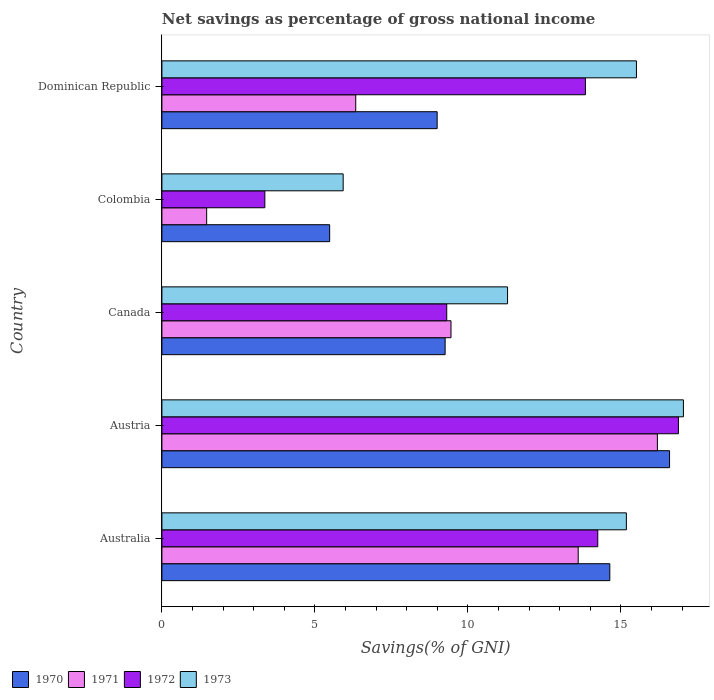Are the number of bars per tick equal to the number of legend labels?
Provide a succinct answer. Yes. How many bars are there on the 2nd tick from the bottom?
Offer a very short reply. 4. What is the label of the 3rd group of bars from the top?
Provide a short and direct response. Canada. In how many cases, is the number of bars for a given country not equal to the number of legend labels?
Your response must be concise. 0. What is the total savings in 1971 in Colombia?
Make the answer very short. 1.46. Across all countries, what is the maximum total savings in 1970?
Your response must be concise. 16.59. Across all countries, what is the minimum total savings in 1972?
Offer a terse response. 3.36. In which country was the total savings in 1972 maximum?
Make the answer very short. Austria. What is the total total savings in 1973 in the graph?
Ensure brevity in your answer.  64.94. What is the difference between the total savings in 1971 in Australia and that in Canada?
Your answer should be very brief. 4.16. What is the difference between the total savings in 1970 in Dominican Republic and the total savings in 1972 in Australia?
Your answer should be compact. -5.25. What is the average total savings in 1970 per country?
Provide a succinct answer. 10.99. What is the difference between the total savings in 1973 and total savings in 1970 in Dominican Republic?
Provide a short and direct response. 6.51. What is the ratio of the total savings in 1972 in Colombia to that in Dominican Republic?
Offer a very short reply. 0.24. Is the difference between the total savings in 1973 in Colombia and Dominican Republic greater than the difference between the total savings in 1970 in Colombia and Dominican Republic?
Provide a short and direct response. No. What is the difference between the highest and the second highest total savings in 1970?
Provide a short and direct response. 1.95. What is the difference between the highest and the lowest total savings in 1970?
Your answer should be very brief. 11.11. In how many countries, is the total savings in 1971 greater than the average total savings in 1971 taken over all countries?
Provide a succinct answer. 3. Is it the case that in every country, the sum of the total savings in 1972 and total savings in 1971 is greater than the total savings in 1970?
Make the answer very short. No. How many countries are there in the graph?
Provide a short and direct response. 5. What is the difference between two consecutive major ticks on the X-axis?
Provide a succinct answer. 5. Are the values on the major ticks of X-axis written in scientific E-notation?
Offer a very short reply. No. Does the graph contain any zero values?
Provide a short and direct response. No. Does the graph contain grids?
Your answer should be very brief. No. Where does the legend appear in the graph?
Give a very brief answer. Bottom left. How many legend labels are there?
Your response must be concise. 4. How are the legend labels stacked?
Offer a very short reply. Horizontal. What is the title of the graph?
Give a very brief answer. Net savings as percentage of gross national income. Does "1987" appear as one of the legend labels in the graph?
Ensure brevity in your answer.  No. What is the label or title of the X-axis?
Your answer should be very brief. Savings(% of GNI). What is the Savings(% of GNI) of 1970 in Australia?
Provide a short and direct response. 14.63. What is the Savings(% of GNI) in 1971 in Australia?
Your answer should be very brief. 13.6. What is the Savings(% of GNI) of 1972 in Australia?
Ensure brevity in your answer.  14.24. What is the Savings(% of GNI) in 1973 in Australia?
Give a very brief answer. 15.18. What is the Savings(% of GNI) of 1970 in Austria?
Your response must be concise. 16.59. What is the Savings(% of GNI) in 1971 in Austria?
Give a very brief answer. 16.19. What is the Savings(% of GNI) in 1972 in Austria?
Make the answer very short. 16.88. What is the Savings(% of GNI) in 1973 in Austria?
Your answer should be very brief. 17.04. What is the Savings(% of GNI) of 1970 in Canada?
Offer a very short reply. 9.25. What is the Savings(% of GNI) of 1971 in Canada?
Provide a short and direct response. 9.45. What is the Savings(% of GNI) in 1972 in Canada?
Keep it short and to the point. 9.31. What is the Savings(% of GNI) in 1973 in Canada?
Offer a terse response. 11.29. What is the Savings(% of GNI) of 1970 in Colombia?
Offer a terse response. 5.48. What is the Savings(% of GNI) of 1971 in Colombia?
Offer a very short reply. 1.46. What is the Savings(% of GNI) of 1972 in Colombia?
Provide a succinct answer. 3.36. What is the Savings(% of GNI) of 1973 in Colombia?
Offer a terse response. 5.92. What is the Savings(% of GNI) of 1970 in Dominican Republic?
Give a very brief answer. 8.99. What is the Savings(% of GNI) in 1971 in Dominican Republic?
Provide a succinct answer. 6.33. What is the Savings(% of GNI) of 1972 in Dominican Republic?
Keep it short and to the point. 13.84. What is the Savings(% of GNI) of 1973 in Dominican Republic?
Give a very brief answer. 15.5. Across all countries, what is the maximum Savings(% of GNI) of 1970?
Give a very brief answer. 16.59. Across all countries, what is the maximum Savings(% of GNI) of 1971?
Offer a terse response. 16.19. Across all countries, what is the maximum Savings(% of GNI) of 1972?
Keep it short and to the point. 16.88. Across all countries, what is the maximum Savings(% of GNI) in 1973?
Your answer should be very brief. 17.04. Across all countries, what is the minimum Savings(% of GNI) of 1970?
Your response must be concise. 5.48. Across all countries, what is the minimum Savings(% of GNI) of 1971?
Offer a very short reply. 1.46. Across all countries, what is the minimum Savings(% of GNI) of 1972?
Give a very brief answer. 3.36. Across all countries, what is the minimum Savings(% of GNI) of 1973?
Your answer should be compact. 5.92. What is the total Savings(% of GNI) in 1970 in the graph?
Provide a short and direct response. 54.95. What is the total Savings(% of GNI) in 1971 in the graph?
Give a very brief answer. 47.03. What is the total Savings(% of GNI) in 1972 in the graph?
Give a very brief answer. 57.63. What is the total Savings(% of GNI) of 1973 in the graph?
Your answer should be very brief. 64.94. What is the difference between the Savings(% of GNI) of 1970 in Australia and that in Austria?
Keep it short and to the point. -1.95. What is the difference between the Savings(% of GNI) of 1971 in Australia and that in Austria?
Provide a short and direct response. -2.59. What is the difference between the Savings(% of GNI) in 1972 in Australia and that in Austria?
Your response must be concise. -2.64. What is the difference between the Savings(% of GNI) of 1973 in Australia and that in Austria?
Provide a short and direct response. -1.86. What is the difference between the Savings(% of GNI) of 1970 in Australia and that in Canada?
Give a very brief answer. 5.38. What is the difference between the Savings(% of GNI) in 1971 in Australia and that in Canada?
Your answer should be compact. 4.16. What is the difference between the Savings(% of GNI) in 1972 in Australia and that in Canada?
Offer a terse response. 4.93. What is the difference between the Savings(% of GNI) in 1973 in Australia and that in Canada?
Provide a succinct answer. 3.88. What is the difference between the Savings(% of GNI) of 1970 in Australia and that in Colombia?
Offer a very short reply. 9.15. What is the difference between the Savings(% of GNI) in 1971 in Australia and that in Colombia?
Your answer should be very brief. 12.14. What is the difference between the Savings(% of GNI) in 1972 in Australia and that in Colombia?
Offer a very short reply. 10.88. What is the difference between the Savings(% of GNI) in 1973 in Australia and that in Colombia?
Give a very brief answer. 9.25. What is the difference between the Savings(% of GNI) in 1970 in Australia and that in Dominican Republic?
Your response must be concise. 5.64. What is the difference between the Savings(% of GNI) of 1971 in Australia and that in Dominican Republic?
Your answer should be compact. 7.27. What is the difference between the Savings(% of GNI) of 1972 in Australia and that in Dominican Republic?
Provide a short and direct response. 0.4. What is the difference between the Savings(% of GNI) in 1973 in Australia and that in Dominican Republic?
Your response must be concise. -0.33. What is the difference between the Savings(% of GNI) of 1970 in Austria and that in Canada?
Keep it short and to the point. 7.33. What is the difference between the Savings(% of GNI) of 1971 in Austria and that in Canada?
Your response must be concise. 6.74. What is the difference between the Savings(% of GNI) in 1972 in Austria and that in Canada?
Provide a succinct answer. 7.57. What is the difference between the Savings(% of GNI) of 1973 in Austria and that in Canada?
Provide a short and direct response. 5.75. What is the difference between the Savings(% of GNI) of 1970 in Austria and that in Colombia?
Your answer should be very brief. 11.11. What is the difference between the Savings(% of GNI) in 1971 in Austria and that in Colombia?
Ensure brevity in your answer.  14.73. What is the difference between the Savings(% of GNI) of 1972 in Austria and that in Colombia?
Your answer should be compact. 13.51. What is the difference between the Savings(% of GNI) in 1973 in Austria and that in Colombia?
Keep it short and to the point. 11.12. What is the difference between the Savings(% of GNI) in 1970 in Austria and that in Dominican Republic?
Offer a terse response. 7.59. What is the difference between the Savings(% of GNI) of 1971 in Austria and that in Dominican Republic?
Make the answer very short. 9.86. What is the difference between the Savings(% of GNI) of 1972 in Austria and that in Dominican Republic?
Your answer should be very brief. 3.04. What is the difference between the Savings(% of GNI) of 1973 in Austria and that in Dominican Republic?
Offer a very short reply. 1.54. What is the difference between the Savings(% of GNI) in 1970 in Canada and that in Colombia?
Provide a succinct answer. 3.77. What is the difference between the Savings(% of GNI) in 1971 in Canada and that in Colombia?
Keep it short and to the point. 7.98. What is the difference between the Savings(% of GNI) in 1972 in Canada and that in Colombia?
Ensure brevity in your answer.  5.94. What is the difference between the Savings(% of GNI) of 1973 in Canada and that in Colombia?
Provide a succinct answer. 5.37. What is the difference between the Savings(% of GNI) in 1970 in Canada and that in Dominican Republic?
Offer a very short reply. 0.26. What is the difference between the Savings(% of GNI) in 1971 in Canada and that in Dominican Republic?
Ensure brevity in your answer.  3.11. What is the difference between the Savings(% of GNI) in 1972 in Canada and that in Dominican Republic?
Make the answer very short. -4.53. What is the difference between the Savings(% of GNI) in 1973 in Canada and that in Dominican Republic?
Ensure brevity in your answer.  -4.21. What is the difference between the Savings(% of GNI) of 1970 in Colombia and that in Dominican Republic?
Offer a terse response. -3.51. What is the difference between the Savings(% of GNI) of 1971 in Colombia and that in Dominican Republic?
Offer a very short reply. -4.87. What is the difference between the Savings(% of GNI) in 1972 in Colombia and that in Dominican Republic?
Your answer should be very brief. -10.47. What is the difference between the Savings(% of GNI) of 1973 in Colombia and that in Dominican Republic?
Keep it short and to the point. -9.58. What is the difference between the Savings(% of GNI) in 1970 in Australia and the Savings(% of GNI) in 1971 in Austria?
Ensure brevity in your answer.  -1.55. What is the difference between the Savings(% of GNI) in 1970 in Australia and the Savings(% of GNI) in 1972 in Austria?
Your answer should be very brief. -2.24. What is the difference between the Savings(% of GNI) in 1970 in Australia and the Savings(% of GNI) in 1973 in Austria?
Provide a succinct answer. -2.4. What is the difference between the Savings(% of GNI) in 1971 in Australia and the Savings(% of GNI) in 1972 in Austria?
Ensure brevity in your answer.  -3.27. What is the difference between the Savings(% of GNI) in 1971 in Australia and the Savings(% of GNI) in 1973 in Austria?
Provide a short and direct response. -3.44. What is the difference between the Savings(% of GNI) in 1972 in Australia and the Savings(% of GNI) in 1973 in Austria?
Provide a short and direct response. -2.8. What is the difference between the Savings(% of GNI) in 1970 in Australia and the Savings(% of GNI) in 1971 in Canada?
Provide a short and direct response. 5.19. What is the difference between the Savings(% of GNI) of 1970 in Australia and the Savings(% of GNI) of 1972 in Canada?
Offer a very short reply. 5.33. What is the difference between the Savings(% of GNI) in 1970 in Australia and the Savings(% of GNI) in 1973 in Canada?
Keep it short and to the point. 3.34. What is the difference between the Savings(% of GNI) in 1971 in Australia and the Savings(% of GNI) in 1972 in Canada?
Offer a very short reply. 4.3. What is the difference between the Savings(% of GNI) in 1971 in Australia and the Savings(% of GNI) in 1973 in Canada?
Ensure brevity in your answer.  2.31. What is the difference between the Savings(% of GNI) of 1972 in Australia and the Savings(% of GNI) of 1973 in Canada?
Your answer should be very brief. 2.95. What is the difference between the Savings(% of GNI) of 1970 in Australia and the Savings(% of GNI) of 1971 in Colombia?
Keep it short and to the point. 13.17. What is the difference between the Savings(% of GNI) in 1970 in Australia and the Savings(% of GNI) in 1972 in Colombia?
Offer a very short reply. 11.27. What is the difference between the Savings(% of GNI) in 1970 in Australia and the Savings(% of GNI) in 1973 in Colombia?
Your answer should be compact. 8.71. What is the difference between the Savings(% of GNI) in 1971 in Australia and the Savings(% of GNI) in 1972 in Colombia?
Offer a very short reply. 10.24. What is the difference between the Savings(% of GNI) in 1971 in Australia and the Savings(% of GNI) in 1973 in Colombia?
Make the answer very short. 7.68. What is the difference between the Savings(% of GNI) of 1972 in Australia and the Savings(% of GNI) of 1973 in Colombia?
Provide a succinct answer. 8.32. What is the difference between the Savings(% of GNI) of 1970 in Australia and the Savings(% of GNI) of 1971 in Dominican Republic?
Ensure brevity in your answer.  8.3. What is the difference between the Savings(% of GNI) in 1970 in Australia and the Savings(% of GNI) in 1972 in Dominican Republic?
Your answer should be compact. 0.8. What is the difference between the Savings(% of GNI) of 1970 in Australia and the Savings(% of GNI) of 1973 in Dominican Republic?
Your answer should be very brief. -0.87. What is the difference between the Savings(% of GNI) in 1971 in Australia and the Savings(% of GNI) in 1972 in Dominican Republic?
Your answer should be very brief. -0.24. What is the difference between the Savings(% of GNI) of 1971 in Australia and the Savings(% of GNI) of 1973 in Dominican Republic?
Make the answer very short. -1.9. What is the difference between the Savings(% of GNI) of 1972 in Australia and the Savings(% of GNI) of 1973 in Dominican Republic?
Make the answer very short. -1.26. What is the difference between the Savings(% of GNI) of 1970 in Austria and the Savings(% of GNI) of 1971 in Canada?
Make the answer very short. 7.14. What is the difference between the Savings(% of GNI) of 1970 in Austria and the Savings(% of GNI) of 1972 in Canada?
Ensure brevity in your answer.  7.28. What is the difference between the Savings(% of GNI) of 1970 in Austria and the Savings(% of GNI) of 1973 in Canada?
Give a very brief answer. 5.29. What is the difference between the Savings(% of GNI) in 1971 in Austria and the Savings(% of GNI) in 1972 in Canada?
Provide a succinct answer. 6.88. What is the difference between the Savings(% of GNI) of 1971 in Austria and the Savings(% of GNI) of 1973 in Canada?
Your answer should be very brief. 4.9. What is the difference between the Savings(% of GNI) of 1972 in Austria and the Savings(% of GNI) of 1973 in Canada?
Offer a very short reply. 5.58. What is the difference between the Savings(% of GNI) in 1970 in Austria and the Savings(% of GNI) in 1971 in Colombia?
Provide a succinct answer. 15.12. What is the difference between the Savings(% of GNI) of 1970 in Austria and the Savings(% of GNI) of 1972 in Colombia?
Offer a terse response. 13.22. What is the difference between the Savings(% of GNI) of 1970 in Austria and the Savings(% of GNI) of 1973 in Colombia?
Provide a succinct answer. 10.66. What is the difference between the Savings(% of GNI) in 1971 in Austria and the Savings(% of GNI) in 1972 in Colombia?
Your answer should be compact. 12.83. What is the difference between the Savings(% of GNI) in 1971 in Austria and the Savings(% of GNI) in 1973 in Colombia?
Provide a succinct answer. 10.27. What is the difference between the Savings(% of GNI) of 1972 in Austria and the Savings(% of GNI) of 1973 in Colombia?
Make the answer very short. 10.95. What is the difference between the Savings(% of GNI) in 1970 in Austria and the Savings(% of GNI) in 1971 in Dominican Republic?
Offer a very short reply. 10.25. What is the difference between the Savings(% of GNI) of 1970 in Austria and the Savings(% of GNI) of 1972 in Dominican Republic?
Keep it short and to the point. 2.75. What is the difference between the Savings(% of GNI) in 1970 in Austria and the Savings(% of GNI) in 1973 in Dominican Republic?
Provide a succinct answer. 1.08. What is the difference between the Savings(% of GNI) of 1971 in Austria and the Savings(% of GNI) of 1972 in Dominican Republic?
Provide a short and direct response. 2.35. What is the difference between the Savings(% of GNI) in 1971 in Austria and the Savings(% of GNI) in 1973 in Dominican Republic?
Your response must be concise. 0.69. What is the difference between the Savings(% of GNI) of 1972 in Austria and the Savings(% of GNI) of 1973 in Dominican Republic?
Provide a succinct answer. 1.37. What is the difference between the Savings(% of GNI) in 1970 in Canada and the Savings(% of GNI) in 1971 in Colombia?
Provide a succinct answer. 7.79. What is the difference between the Savings(% of GNI) of 1970 in Canada and the Savings(% of GNI) of 1972 in Colombia?
Offer a very short reply. 5.89. What is the difference between the Savings(% of GNI) of 1970 in Canada and the Savings(% of GNI) of 1973 in Colombia?
Make the answer very short. 3.33. What is the difference between the Savings(% of GNI) of 1971 in Canada and the Savings(% of GNI) of 1972 in Colombia?
Provide a short and direct response. 6.08. What is the difference between the Savings(% of GNI) of 1971 in Canada and the Savings(% of GNI) of 1973 in Colombia?
Ensure brevity in your answer.  3.52. What is the difference between the Savings(% of GNI) of 1972 in Canada and the Savings(% of GNI) of 1973 in Colombia?
Keep it short and to the point. 3.38. What is the difference between the Savings(% of GNI) in 1970 in Canada and the Savings(% of GNI) in 1971 in Dominican Republic?
Your answer should be compact. 2.92. What is the difference between the Savings(% of GNI) in 1970 in Canada and the Savings(% of GNI) in 1972 in Dominican Republic?
Your answer should be very brief. -4.58. What is the difference between the Savings(% of GNI) in 1970 in Canada and the Savings(% of GNI) in 1973 in Dominican Republic?
Provide a short and direct response. -6.25. What is the difference between the Savings(% of GNI) of 1971 in Canada and the Savings(% of GNI) of 1972 in Dominican Republic?
Your answer should be very brief. -4.39. What is the difference between the Savings(% of GNI) of 1971 in Canada and the Savings(% of GNI) of 1973 in Dominican Republic?
Make the answer very short. -6.06. What is the difference between the Savings(% of GNI) in 1972 in Canada and the Savings(% of GNI) in 1973 in Dominican Republic?
Offer a terse response. -6.2. What is the difference between the Savings(% of GNI) of 1970 in Colombia and the Savings(% of GNI) of 1971 in Dominican Republic?
Your answer should be very brief. -0.85. What is the difference between the Savings(% of GNI) in 1970 in Colombia and the Savings(% of GNI) in 1972 in Dominican Republic?
Make the answer very short. -8.36. What is the difference between the Savings(% of GNI) in 1970 in Colombia and the Savings(% of GNI) in 1973 in Dominican Republic?
Keep it short and to the point. -10.02. What is the difference between the Savings(% of GNI) of 1971 in Colombia and the Savings(% of GNI) of 1972 in Dominican Republic?
Your response must be concise. -12.38. What is the difference between the Savings(% of GNI) in 1971 in Colombia and the Savings(% of GNI) in 1973 in Dominican Republic?
Offer a terse response. -14.04. What is the difference between the Savings(% of GNI) of 1972 in Colombia and the Savings(% of GNI) of 1973 in Dominican Republic?
Ensure brevity in your answer.  -12.14. What is the average Savings(% of GNI) in 1970 per country?
Give a very brief answer. 10.99. What is the average Savings(% of GNI) of 1971 per country?
Your response must be concise. 9.41. What is the average Savings(% of GNI) in 1972 per country?
Ensure brevity in your answer.  11.53. What is the average Savings(% of GNI) in 1973 per country?
Provide a short and direct response. 12.99. What is the difference between the Savings(% of GNI) in 1970 and Savings(% of GNI) in 1971 in Australia?
Keep it short and to the point. 1.03. What is the difference between the Savings(% of GNI) of 1970 and Savings(% of GNI) of 1972 in Australia?
Ensure brevity in your answer.  0.39. What is the difference between the Savings(% of GNI) of 1970 and Savings(% of GNI) of 1973 in Australia?
Provide a succinct answer. -0.54. What is the difference between the Savings(% of GNI) in 1971 and Savings(% of GNI) in 1972 in Australia?
Your response must be concise. -0.64. What is the difference between the Savings(% of GNI) in 1971 and Savings(% of GNI) in 1973 in Australia?
Give a very brief answer. -1.57. What is the difference between the Savings(% of GNI) in 1972 and Savings(% of GNI) in 1973 in Australia?
Provide a succinct answer. -0.93. What is the difference between the Savings(% of GNI) of 1970 and Savings(% of GNI) of 1971 in Austria?
Your answer should be compact. 0.4. What is the difference between the Savings(% of GNI) of 1970 and Savings(% of GNI) of 1972 in Austria?
Give a very brief answer. -0.29. What is the difference between the Savings(% of GNI) in 1970 and Savings(% of GNI) in 1973 in Austria?
Give a very brief answer. -0.45. What is the difference between the Savings(% of GNI) in 1971 and Savings(% of GNI) in 1972 in Austria?
Provide a succinct answer. -0.69. What is the difference between the Savings(% of GNI) of 1971 and Savings(% of GNI) of 1973 in Austria?
Offer a very short reply. -0.85. What is the difference between the Savings(% of GNI) in 1972 and Savings(% of GNI) in 1973 in Austria?
Make the answer very short. -0.16. What is the difference between the Savings(% of GNI) of 1970 and Savings(% of GNI) of 1971 in Canada?
Provide a short and direct response. -0.19. What is the difference between the Savings(% of GNI) in 1970 and Savings(% of GNI) in 1972 in Canada?
Your response must be concise. -0.05. What is the difference between the Savings(% of GNI) in 1970 and Savings(% of GNI) in 1973 in Canada?
Make the answer very short. -2.04. What is the difference between the Savings(% of GNI) in 1971 and Savings(% of GNI) in 1972 in Canada?
Provide a succinct answer. 0.14. What is the difference between the Savings(% of GNI) of 1971 and Savings(% of GNI) of 1973 in Canada?
Your answer should be very brief. -1.85. What is the difference between the Savings(% of GNI) of 1972 and Savings(% of GNI) of 1973 in Canada?
Keep it short and to the point. -1.99. What is the difference between the Savings(% of GNI) in 1970 and Savings(% of GNI) in 1971 in Colombia?
Provide a short and direct response. 4.02. What is the difference between the Savings(% of GNI) of 1970 and Savings(% of GNI) of 1972 in Colombia?
Give a very brief answer. 2.12. What is the difference between the Savings(% of GNI) in 1970 and Savings(% of GNI) in 1973 in Colombia?
Give a very brief answer. -0.44. What is the difference between the Savings(% of GNI) in 1971 and Savings(% of GNI) in 1972 in Colombia?
Give a very brief answer. -1.9. What is the difference between the Savings(% of GNI) of 1971 and Savings(% of GNI) of 1973 in Colombia?
Make the answer very short. -4.46. What is the difference between the Savings(% of GNI) of 1972 and Savings(% of GNI) of 1973 in Colombia?
Offer a very short reply. -2.56. What is the difference between the Savings(% of GNI) of 1970 and Savings(% of GNI) of 1971 in Dominican Republic?
Keep it short and to the point. 2.66. What is the difference between the Savings(% of GNI) of 1970 and Savings(% of GNI) of 1972 in Dominican Republic?
Your answer should be very brief. -4.84. What is the difference between the Savings(% of GNI) of 1970 and Savings(% of GNI) of 1973 in Dominican Republic?
Offer a terse response. -6.51. What is the difference between the Savings(% of GNI) of 1971 and Savings(% of GNI) of 1972 in Dominican Republic?
Offer a very short reply. -7.5. What is the difference between the Savings(% of GNI) of 1971 and Savings(% of GNI) of 1973 in Dominican Republic?
Keep it short and to the point. -9.17. What is the difference between the Savings(% of GNI) in 1972 and Savings(% of GNI) in 1973 in Dominican Republic?
Offer a terse response. -1.67. What is the ratio of the Savings(% of GNI) in 1970 in Australia to that in Austria?
Your response must be concise. 0.88. What is the ratio of the Savings(% of GNI) in 1971 in Australia to that in Austria?
Give a very brief answer. 0.84. What is the ratio of the Savings(% of GNI) in 1972 in Australia to that in Austria?
Provide a succinct answer. 0.84. What is the ratio of the Savings(% of GNI) in 1973 in Australia to that in Austria?
Make the answer very short. 0.89. What is the ratio of the Savings(% of GNI) in 1970 in Australia to that in Canada?
Your answer should be very brief. 1.58. What is the ratio of the Savings(% of GNI) of 1971 in Australia to that in Canada?
Offer a terse response. 1.44. What is the ratio of the Savings(% of GNI) of 1972 in Australia to that in Canada?
Your answer should be very brief. 1.53. What is the ratio of the Savings(% of GNI) in 1973 in Australia to that in Canada?
Your response must be concise. 1.34. What is the ratio of the Savings(% of GNI) in 1970 in Australia to that in Colombia?
Your response must be concise. 2.67. What is the ratio of the Savings(% of GNI) of 1971 in Australia to that in Colombia?
Keep it short and to the point. 9.3. What is the ratio of the Savings(% of GNI) of 1972 in Australia to that in Colombia?
Keep it short and to the point. 4.23. What is the ratio of the Savings(% of GNI) of 1973 in Australia to that in Colombia?
Offer a very short reply. 2.56. What is the ratio of the Savings(% of GNI) in 1970 in Australia to that in Dominican Republic?
Offer a very short reply. 1.63. What is the ratio of the Savings(% of GNI) of 1971 in Australia to that in Dominican Republic?
Provide a short and direct response. 2.15. What is the ratio of the Savings(% of GNI) of 1972 in Australia to that in Dominican Republic?
Your response must be concise. 1.03. What is the ratio of the Savings(% of GNI) of 1973 in Australia to that in Dominican Republic?
Offer a terse response. 0.98. What is the ratio of the Savings(% of GNI) of 1970 in Austria to that in Canada?
Your answer should be very brief. 1.79. What is the ratio of the Savings(% of GNI) of 1971 in Austria to that in Canada?
Make the answer very short. 1.71. What is the ratio of the Savings(% of GNI) of 1972 in Austria to that in Canada?
Ensure brevity in your answer.  1.81. What is the ratio of the Savings(% of GNI) in 1973 in Austria to that in Canada?
Give a very brief answer. 1.51. What is the ratio of the Savings(% of GNI) of 1970 in Austria to that in Colombia?
Your answer should be compact. 3.03. What is the ratio of the Savings(% of GNI) in 1971 in Austria to that in Colombia?
Your response must be concise. 11.07. What is the ratio of the Savings(% of GNI) in 1972 in Austria to that in Colombia?
Give a very brief answer. 5.02. What is the ratio of the Savings(% of GNI) of 1973 in Austria to that in Colombia?
Your answer should be compact. 2.88. What is the ratio of the Savings(% of GNI) in 1970 in Austria to that in Dominican Republic?
Make the answer very short. 1.84. What is the ratio of the Savings(% of GNI) in 1971 in Austria to that in Dominican Republic?
Offer a very short reply. 2.56. What is the ratio of the Savings(% of GNI) in 1972 in Austria to that in Dominican Republic?
Keep it short and to the point. 1.22. What is the ratio of the Savings(% of GNI) of 1973 in Austria to that in Dominican Republic?
Your response must be concise. 1.1. What is the ratio of the Savings(% of GNI) of 1970 in Canada to that in Colombia?
Make the answer very short. 1.69. What is the ratio of the Savings(% of GNI) in 1971 in Canada to that in Colombia?
Provide a succinct answer. 6.46. What is the ratio of the Savings(% of GNI) of 1972 in Canada to that in Colombia?
Your response must be concise. 2.77. What is the ratio of the Savings(% of GNI) in 1973 in Canada to that in Colombia?
Your answer should be compact. 1.91. What is the ratio of the Savings(% of GNI) in 1971 in Canada to that in Dominican Republic?
Your answer should be very brief. 1.49. What is the ratio of the Savings(% of GNI) in 1972 in Canada to that in Dominican Republic?
Ensure brevity in your answer.  0.67. What is the ratio of the Savings(% of GNI) in 1973 in Canada to that in Dominican Republic?
Your answer should be very brief. 0.73. What is the ratio of the Savings(% of GNI) in 1970 in Colombia to that in Dominican Republic?
Keep it short and to the point. 0.61. What is the ratio of the Savings(% of GNI) in 1971 in Colombia to that in Dominican Republic?
Provide a succinct answer. 0.23. What is the ratio of the Savings(% of GNI) in 1972 in Colombia to that in Dominican Republic?
Your answer should be compact. 0.24. What is the ratio of the Savings(% of GNI) of 1973 in Colombia to that in Dominican Republic?
Provide a succinct answer. 0.38. What is the difference between the highest and the second highest Savings(% of GNI) in 1970?
Give a very brief answer. 1.95. What is the difference between the highest and the second highest Savings(% of GNI) of 1971?
Provide a succinct answer. 2.59. What is the difference between the highest and the second highest Savings(% of GNI) of 1972?
Provide a succinct answer. 2.64. What is the difference between the highest and the second highest Savings(% of GNI) in 1973?
Provide a short and direct response. 1.54. What is the difference between the highest and the lowest Savings(% of GNI) of 1970?
Keep it short and to the point. 11.11. What is the difference between the highest and the lowest Savings(% of GNI) of 1971?
Offer a very short reply. 14.73. What is the difference between the highest and the lowest Savings(% of GNI) in 1972?
Provide a succinct answer. 13.51. What is the difference between the highest and the lowest Savings(% of GNI) in 1973?
Your answer should be very brief. 11.12. 